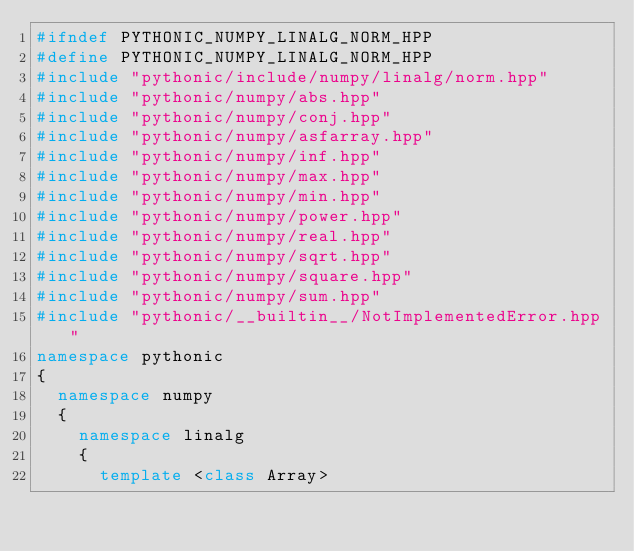<code> <loc_0><loc_0><loc_500><loc_500><_C++_>#ifndef PYTHONIC_NUMPY_LINALG_NORM_HPP
#define PYTHONIC_NUMPY_LINALG_NORM_HPP
#include "pythonic/include/numpy/linalg/norm.hpp"
#include "pythonic/numpy/abs.hpp"
#include "pythonic/numpy/conj.hpp"
#include "pythonic/numpy/asfarray.hpp"
#include "pythonic/numpy/inf.hpp"
#include "pythonic/numpy/max.hpp"
#include "pythonic/numpy/min.hpp"
#include "pythonic/numpy/power.hpp"
#include "pythonic/numpy/real.hpp"
#include "pythonic/numpy/sqrt.hpp"
#include "pythonic/numpy/square.hpp"
#include "pythonic/numpy/sum.hpp"
#include "pythonic/__builtin__/NotImplementedError.hpp"
namespace pythonic
{
  namespace numpy
  {
    namespace linalg
    {
      template <class Array></code> 